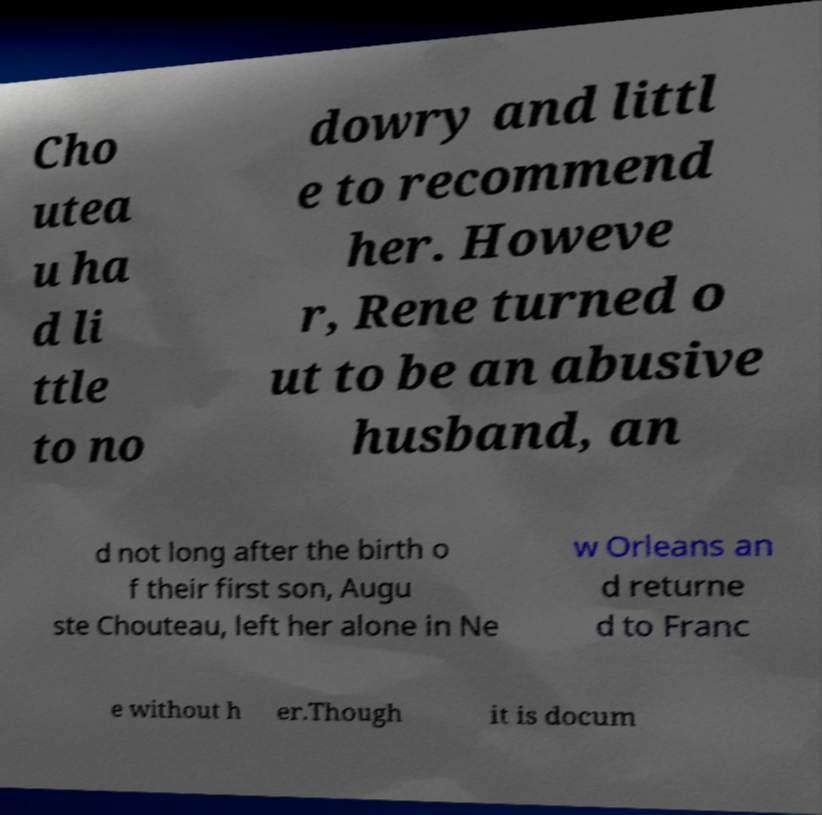Could you extract and type out the text from this image? Cho utea u ha d li ttle to no dowry and littl e to recommend her. Howeve r, Rene turned o ut to be an abusive husband, an d not long after the birth o f their first son, Augu ste Chouteau, left her alone in Ne w Orleans an d returne d to Franc e without h er.Though it is docum 